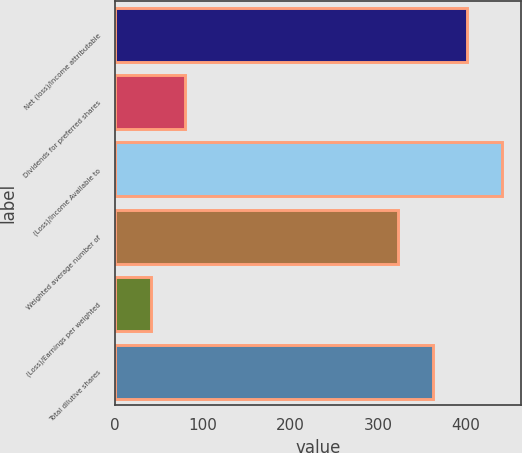<chart> <loc_0><loc_0><loc_500><loc_500><bar_chart><fcel>Net (loss)/income attributable<fcel>Dividends for preferred shares<fcel>(Loss)/Income Available to<fcel>Weighted average number of<fcel>(Loss)/Earnings per weighted<fcel>Total dilutive shares<nl><fcel>401.76<fcel>79.98<fcel>441.14<fcel>323<fcel>40.6<fcel>362.38<nl></chart> 